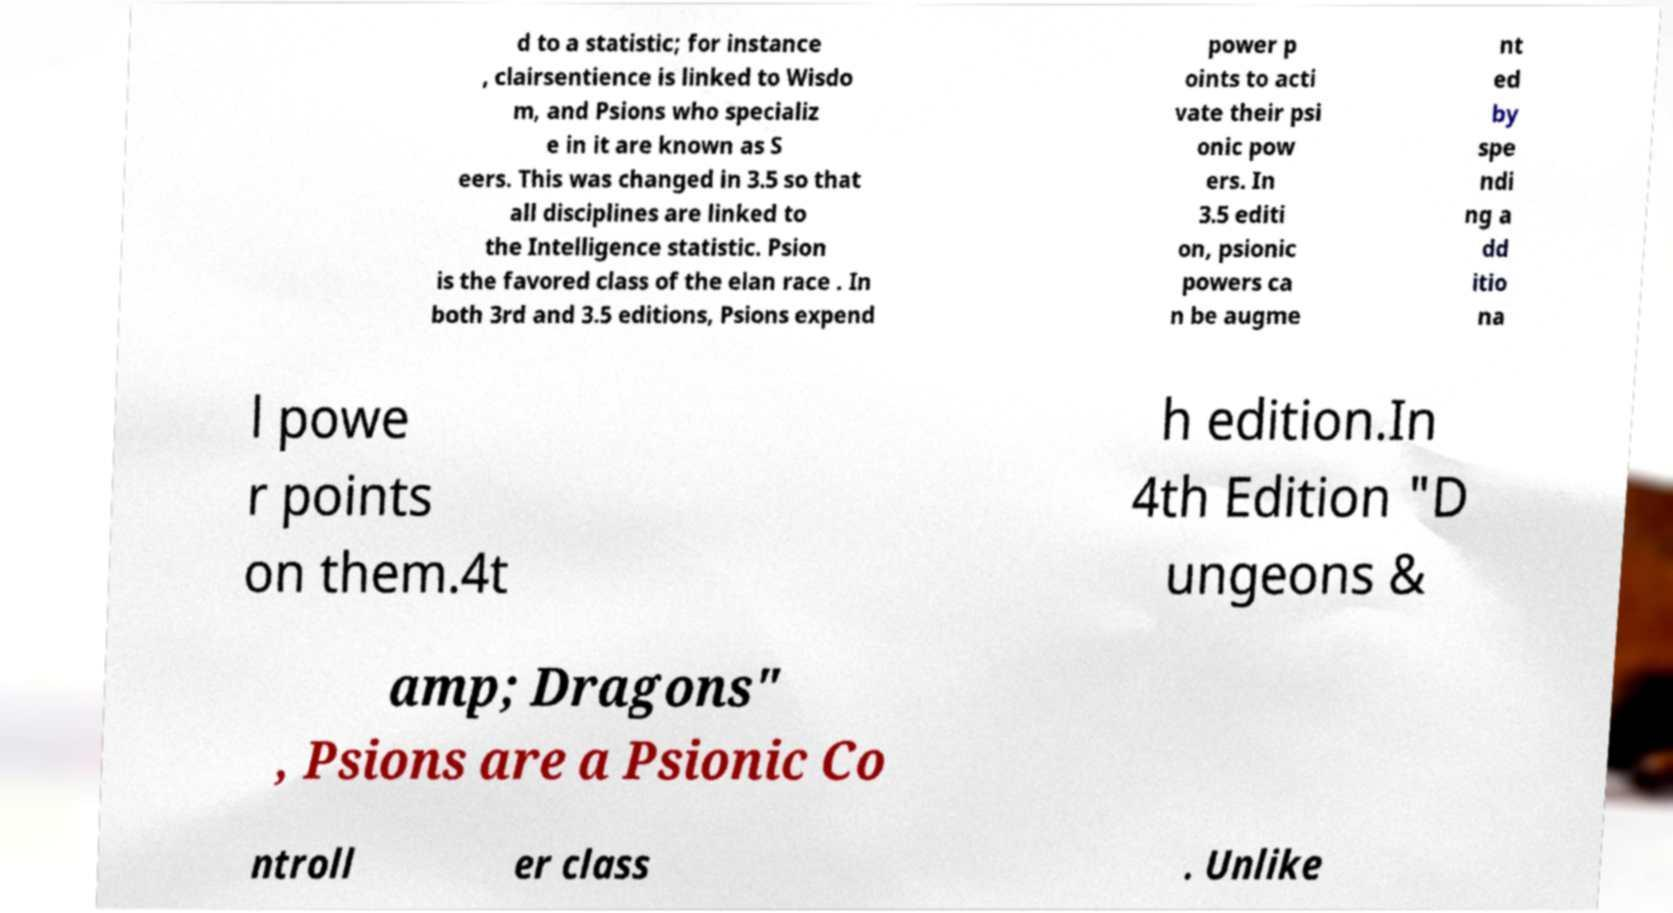What messages or text are displayed in this image? I need them in a readable, typed format. d to a statistic; for instance , clairsentience is linked to Wisdo m, and Psions who specializ e in it are known as S eers. This was changed in 3.5 so that all disciplines are linked to the Intelligence statistic. Psion is the favored class of the elan race . In both 3rd and 3.5 editions, Psions expend power p oints to acti vate their psi onic pow ers. In 3.5 editi on, psionic powers ca n be augme nt ed by spe ndi ng a dd itio na l powe r points on them.4t h edition.In 4th Edition "D ungeons & amp; Dragons" , Psions are a Psionic Co ntroll er class . Unlike 